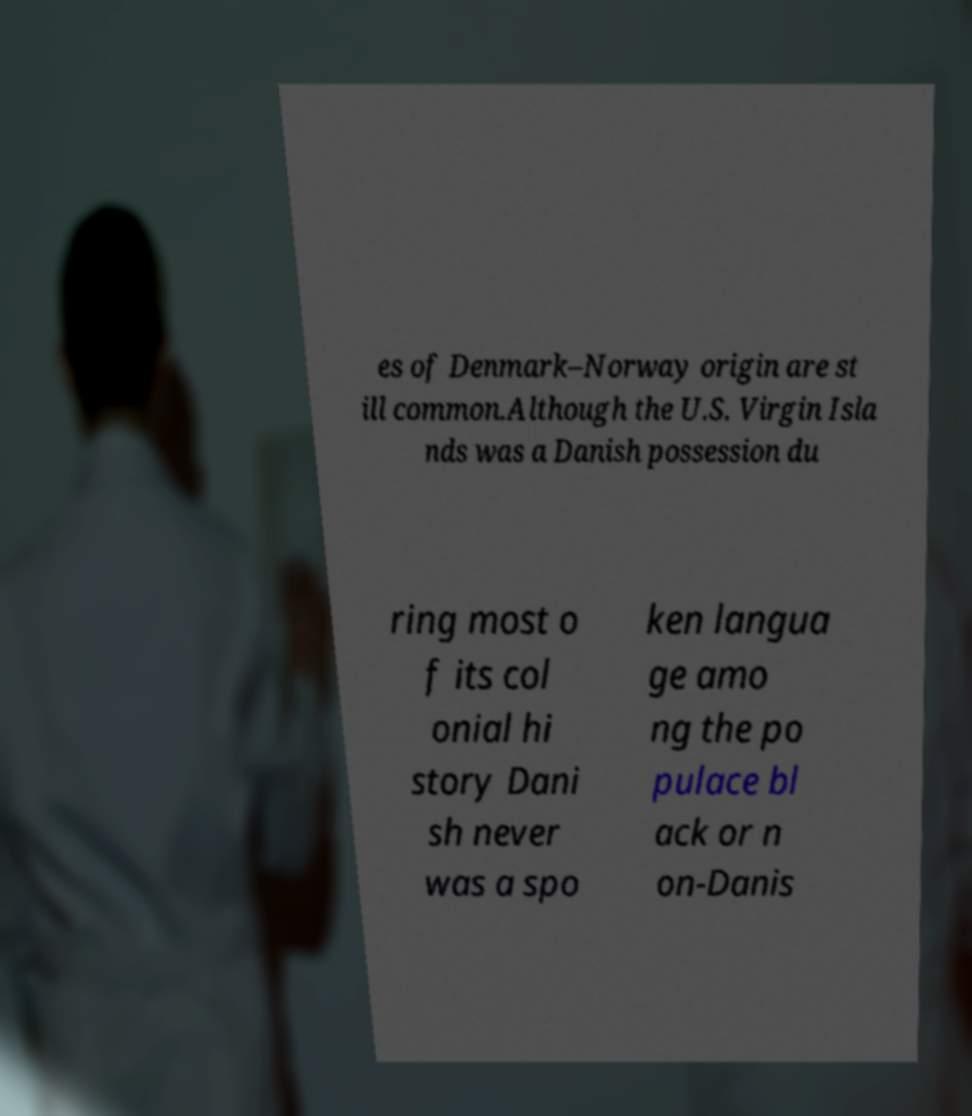Could you extract and type out the text from this image? es of Denmark–Norway origin are st ill common.Although the U.S. Virgin Isla nds was a Danish possession du ring most o f its col onial hi story Dani sh never was a spo ken langua ge amo ng the po pulace bl ack or n on-Danis 